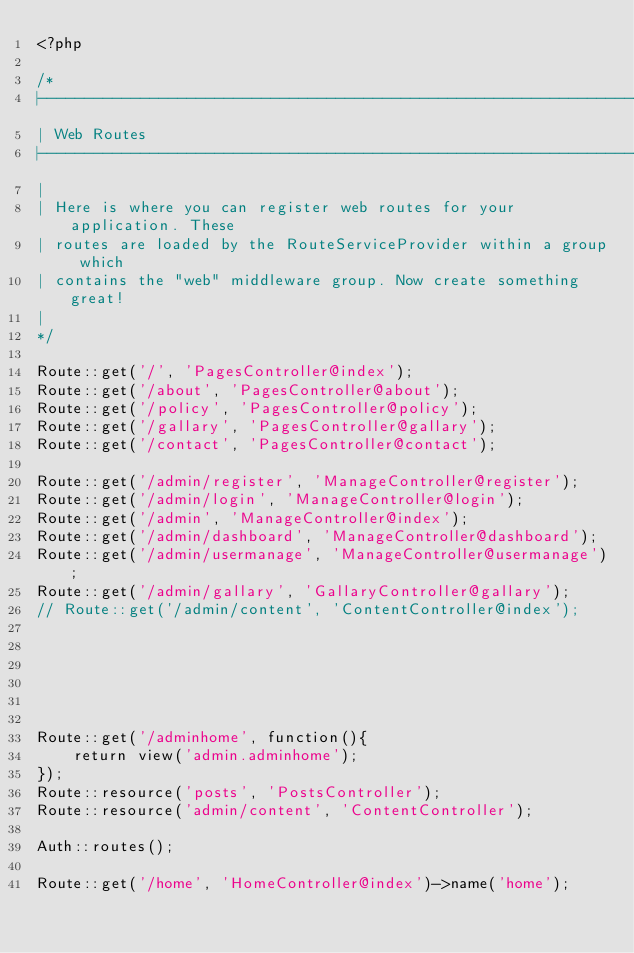Convert code to text. <code><loc_0><loc_0><loc_500><loc_500><_PHP_><?php

/*
|--------------------------------------------------------------------------
| Web Routes
|--------------------------------------------------------------------------
|
| Here is where you can register web routes for your application. These
| routes are loaded by the RouteServiceProvider within a group which
| contains the "web" middleware group. Now create something great!
|
*/

Route::get('/', 'PagesController@index');
Route::get('/about', 'PagesController@about');
Route::get('/policy', 'PagesController@policy');
Route::get('/gallary', 'PagesController@gallary');
Route::get('/contact', 'PagesController@contact');

Route::get('/admin/register', 'ManageController@register');
Route::get('/admin/login', 'ManageController@login');
Route::get('/admin', 'ManageController@index');
Route::get('/admin/dashboard', 'ManageController@dashboard');
Route::get('/admin/usermanage', 'ManageController@usermanage');
Route::get('/admin/gallary', 'GallaryController@gallary');
// Route::get('/admin/content', 'ContentController@index');






Route::get('/adminhome', function(){
	return view('admin.adminhome');
});
Route::resource('posts', 'PostsController');
Route::resource('admin/content', 'ContentController');

Auth::routes();

Route::get('/home', 'HomeController@index')->name('home');

</code> 